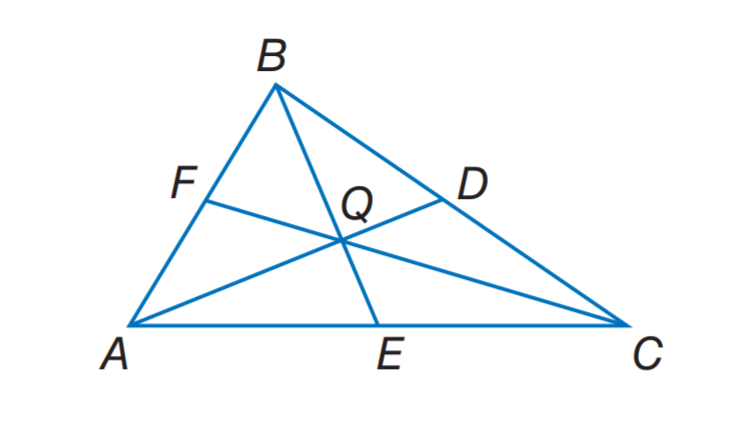Answer the mathemtical geometry problem and directly provide the correct option letter.
Question: Q is the centroid and B E = 9. Find Q E.
Choices: A: 3 B: 6 C: 9 D: 12 A 